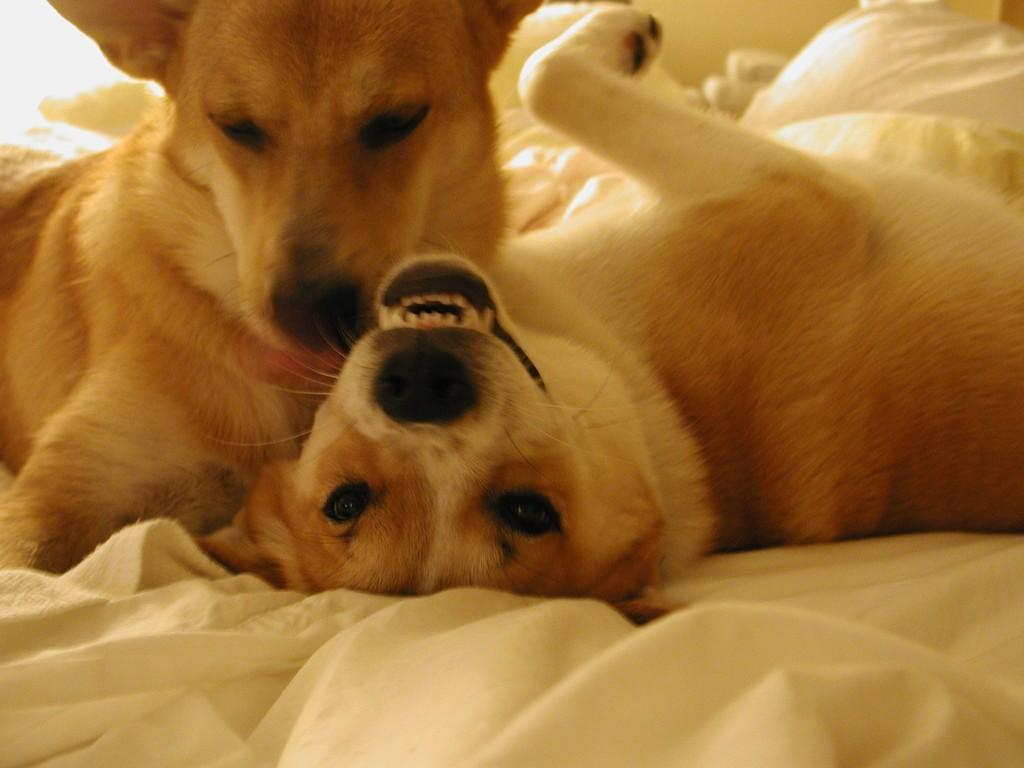How many dogs are present in the image? There are two dogs in the image. What is located at the bottom of the image? There is a cloth at the bottom of the image. What type of bomb can be seen in the image? There is no bomb present in the image; it features two dogs and a cloth. What type of meal is being prepared in the image? There is no meal preparation visible in the image; it only shows two dogs and a cloth. 